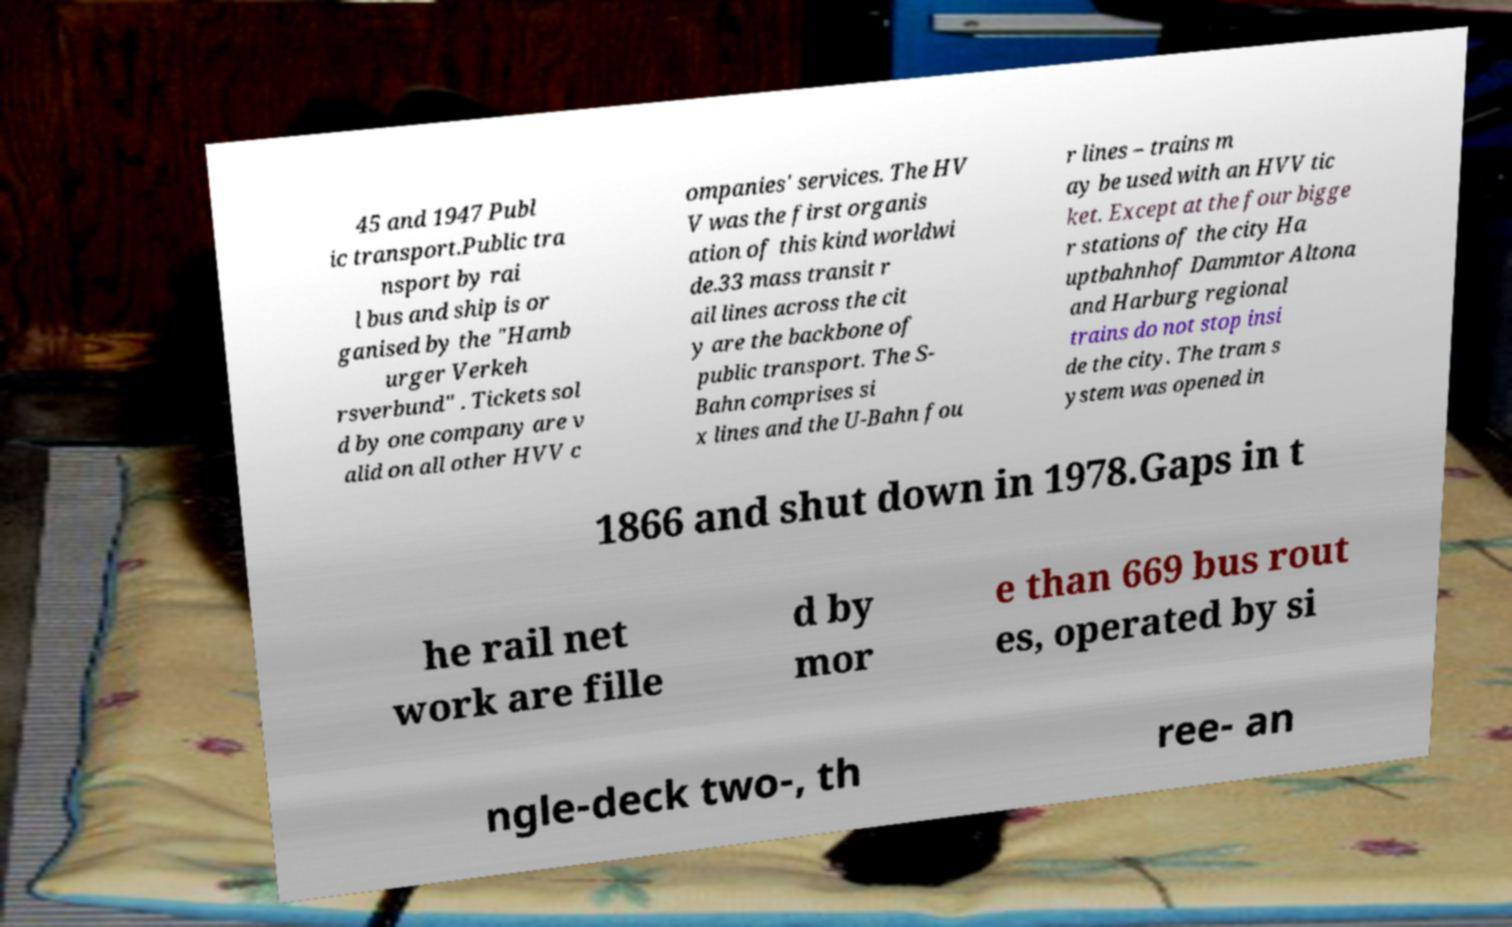Can you read and provide the text displayed in the image?This photo seems to have some interesting text. Can you extract and type it out for me? 45 and 1947 Publ ic transport.Public tra nsport by rai l bus and ship is or ganised by the "Hamb urger Verkeh rsverbund" . Tickets sol d by one company are v alid on all other HVV c ompanies' services. The HV V was the first organis ation of this kind worldwi de.33 mass transit r ail lines across the cit y are the backbone of public transport. The S- Bahn comprises si x lines and the U-Bahn fou r lines – trains m ay be used with an HVV tic ket. Except at the four bigge r stations of the city Ha uptbahnhof Dammtor Altona and Harburg regional trains do not stop insi de the city. The tram s ystem was opened in 1866 and shut down in 1978.Gaps in t he rail net work are fille d by mor e than 669 bus rout es, operated by si ngle-deck two-, th ree- an 